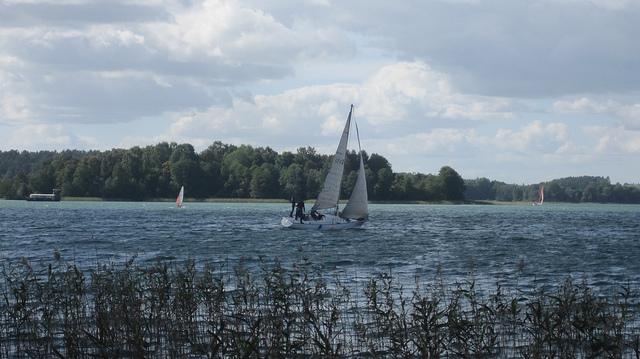What type of vehicle is pictured?
Be succinct. Boat. Is there a ship in the water?
Short answer required. No. How many boats are in the water?
Short answer required. 3. 